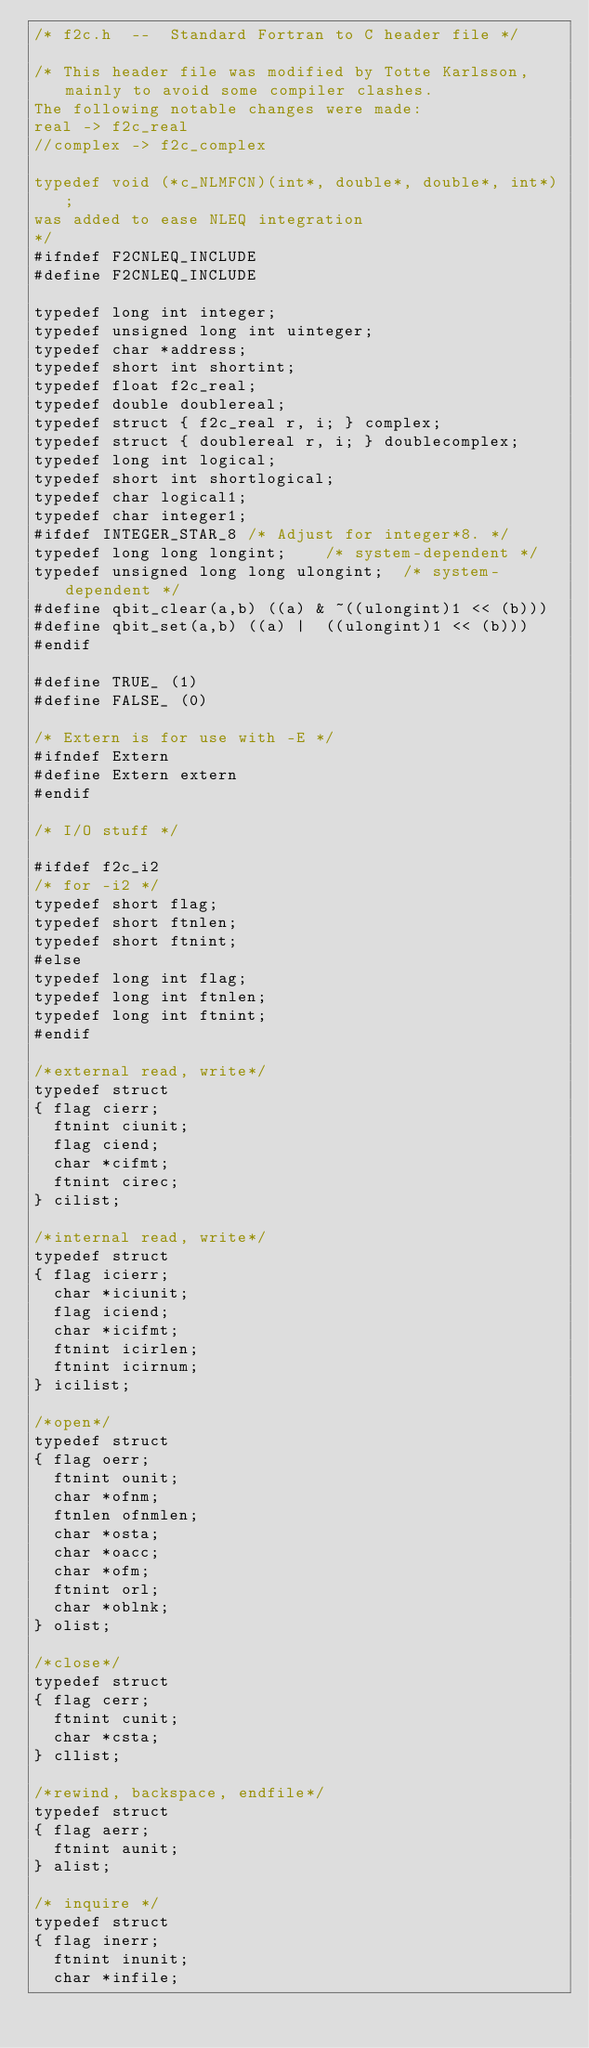Convert code to text. <code><loc_0><loc_0><loc_500><loc_500><_C_>/* f2c.h  --  Standard Fortran to C header file */

/* This header file was modified by Totte Karlsson, mainly to avoid some compiler clashes.
The following notable changes were made:
real -> f2c_real
//complex -> f2c_complex

typedef void (*c_NLMFCN)(int*, double*, double*, int*); 
was added to ease NLEQ integration
*/
#ifndef F2CNLEQ_INCLUDE
#define F2CNLEQ_INCLUDE

typedef long int integer;
typedef unsigned long int uinteger;
typedef char *address;
typedef short int shortint;
typedef float f2c_real;
typedef double doublereal;
typedef struct { f2c_real r, i; } complex;
typedef struct { doublereal r, i; } doublecomplex;
typedef long int logical;
typedef short int shortlogical;
typedef char logical1;
typedef char integer1;
#ifdef INTEGER_STAR_8	/* Adjust for integer*8. */
typedef long long longint;		/* system-dependent */
typedef unsigned long long ulongint;	/* system-dependent */
#define qbit_clear(a,b)	((a) & ~((ulongint)1 << (b)))
#define qbit_set(a,b)	((a) |  ((ulongint)1 << (b)))
#endif

#define TRUE_ (1)
#define FALSE_ (0)

/* Extern is for use with -E */
#ifndef Extern
#define Extern extern
#endif

/* I/O stuff */

#ifdef f2c_i2
/* for -i2 */
typedef short flag;
typedef short ftnlen;
typedef short ftnint;
#else
typedef long int flag;
typedef long int ftnlen;
typedef long int ftnint;
#endif

/*external read, write*/
typedef struct
{	flag cierr;
	ftnint ciunit;
	flag ciend;
	char *cifmt;
	ftnint cirec;
} cilist;

/*internal read, write*/
typedef struct
{	flag icierr;
	char *iciunit;
	flag iciend;
	char *icifmt;
	ftnint icirlen;
	ftnint icirnum;
} icilist;

/*open*/
typedef struct
{	flag oerr;
	ftnint ounit;
	char *ofnm;
	ftnlen ofnmlen;
	char *osta;
	char *oacc;
	char *ofm;
	ftnint orl;
	char *oblnk;
} olist;

/*close*/
typedef struct
{	flag cerr;
	ftnint cunit;
	char *csta;
} cllist;

/*rewind, backspace, endfile*/
typedef struct
{	flag aerr;
	ftnint aunit;
} alist;

/* inquire */
typedef struct
{	flag inerr;
	ftnint inunit;
	char *infile;</code> 